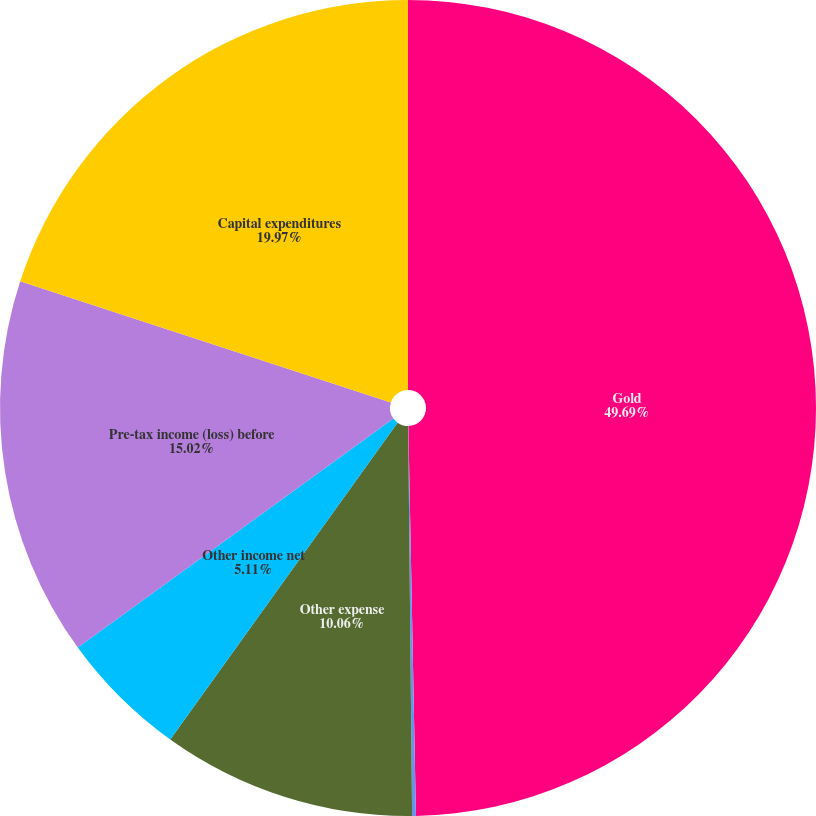<chart> <loc_0><loc_0><loc_500><loc_500><pie_chart><fcel>Gold<fcel>Accretion<fcel>Other expense<fcel>Other income net<fcel>Pre-tax income (loss) before<fcel>Capital expenditures<nl><fcel>49.69%<fcel>0.15%<fcel>10.06%<fcel>5.11%<fcel>15.02%<fcel>19.97%<nl></chart> 